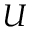Convert formula to latex. <formula><loc_0><loc_0><loc_500><loc_500>U</formula> 